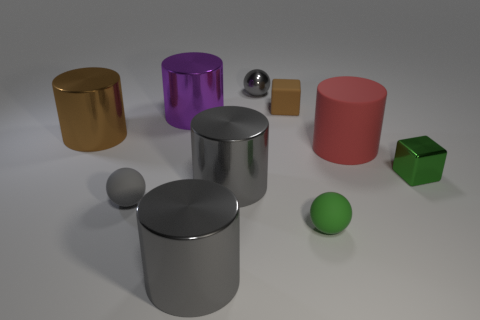There is a small matte object behind the gray rubber thing; does it have the same color as the block on the right side of the tiny brown block?
Offer a very short reply. No. There is a object that is to the right of the green rubber object and in front of the red object; what is its shape?
Keep it short and to the point. Cube. Is there a tiny red rubber object of the same shape as the small gray rubber object?
Offer a terse response. No. There is a green object that is the same size as the green cube; what shape is it?
Your answer should be very brief. Sphere. What is the tiny brown cube made of?
Keep it short and to the point. Rubber. How big is the matte sphere to the right of the tiny gray ball that is in front of the small metal object that is to the right of the red matte thing?
Provide a succinct answer. Small. There is a big thing that is the same color as the rubber block; what is it made of?
Your answer should be very brief. Metal. What number of metal objects are large gray cylinders or cylinders?
Provide a short and direct response. 4. What is the size of the green metal block?
Ensure brevity in your answer.  Small. How many objects are either big gray metallic things or large red matte things that are in front of the large purple object?
Provide a succinct answer. 3. 